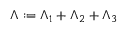Convert formula to latex. <formula><loc_0><loc_0><loc_500><loc_500>\Lambda \colon = \Lambda _ { 1 } + \Lambda _ { 2 } + \Lambda _ { 3 }</formula> 